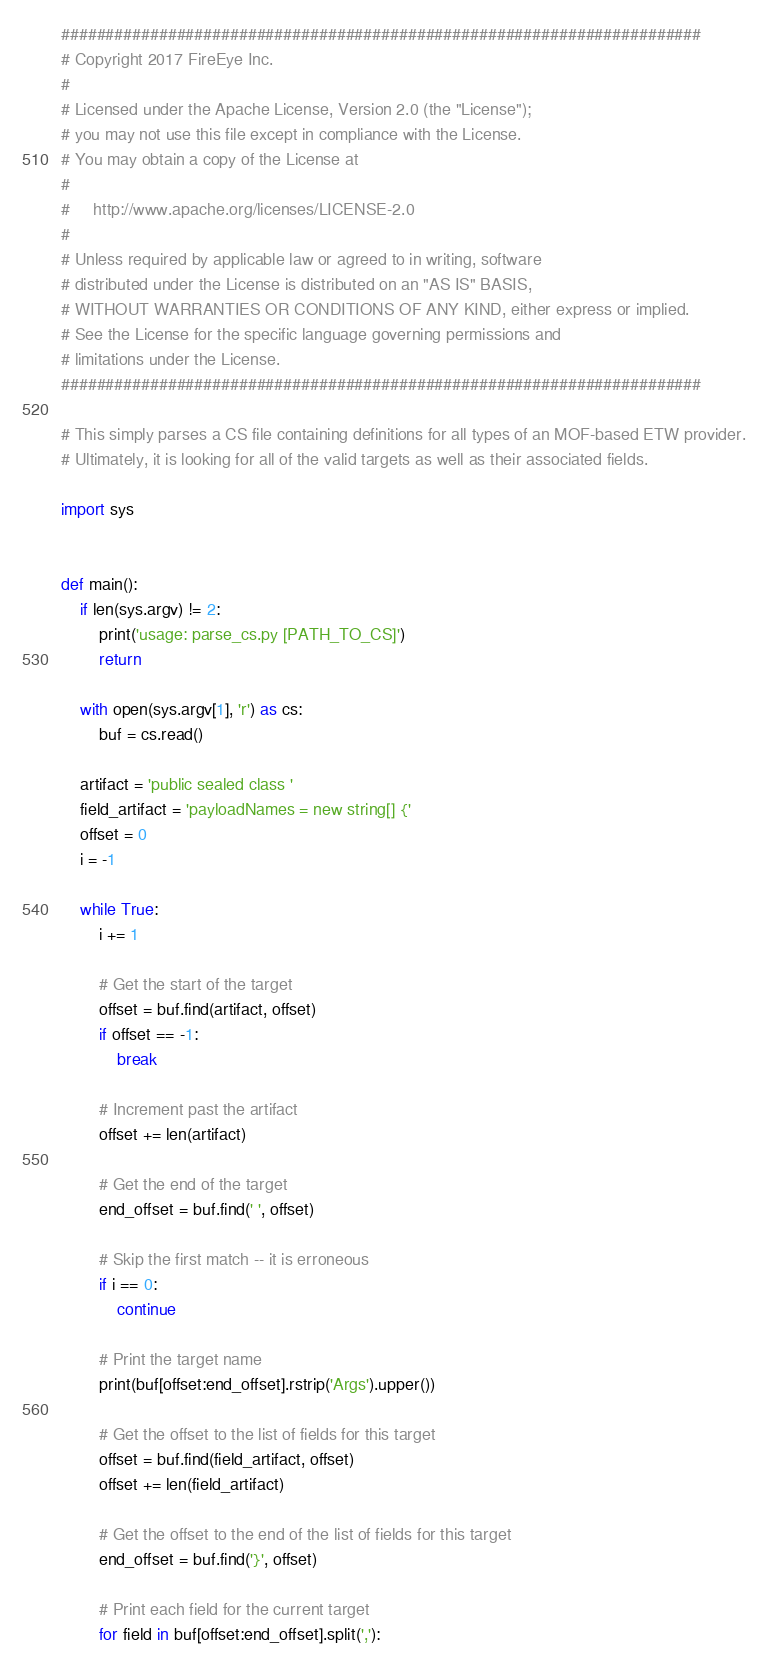<code> <loc_0><loc_0><loc_500><loc_500><_Python_>########################################################################
# Copyright 2017 FireEye Inc.
#
# Licensed under the Apache License, Version 2.0 (the "License");
# you may not use this file except in compliance with the License.
# You may obtain a copy of the License at
#
#     http://www.apache.org/licenses/LICENSE-2.0
#
# Unless required by applicable law or agreed to in writing, software
# distributed under the License is distributed on an "AS IS" BASIS,
# WITHOUT WARRANTIES OR CONDITIONS OF ANY KIND, either express or implied.
# See the License for the specific language governing permissions and
# limitations under the License.
########################################################################

# This simply parses a CS file containing definitions for all types of an MOF-based ETW provider.
# Ultimately, it is looking for all of the valid targets as well as their associated fields.

import sys


def main():
    if len(sys.argv) != 2:
        print('usage: parse_cs.py [PATH_TO_CS]')
        return

    with open(sys.argv[1], 'r') as cs:
        buf = cs.read()

    artifact = 'public sealed class '
    field_artifact = 'payloadNames = new string[] {'
    offset = 0
    i = -1

    while True:
        i += 1

        # Get the start of the target
        offset = buf.find(artifact, offset)
        if offset == -1:
            break

        # Increment past the artifact
        offset += len(artifact)

        # Get the end of the target
        end_offset = buf.find(' ', offset)

        # Skip the first match -- it is erroneous
        if i == 0:
            continue

        # Print the target name
        print(buf[offset:end_offset].rstrip('Args').upper())

        # Get the offset to the list of fields for this target
        offset = buf.find(field_artifact, offset)
        offset += len(field_artifact)

        # Get the offset to the end of the list of fields for this target
        end_offset = buf.find('}', offset)

        # Print each field for the current target
        for field in buf[offset:end_offset].split(','):</code> 